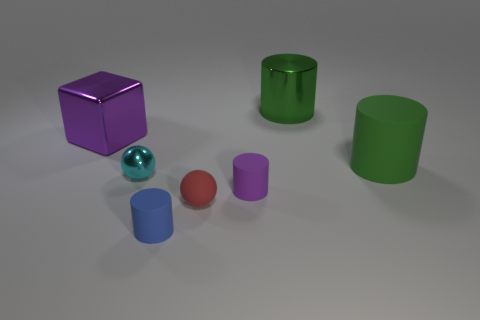Add 2 big purple metallic things. How many objects exist? 9 Subtract all cylinders. How many objects are left? 3 Add 3 metal cubes. How many metal cubes exist? 4 Subtract 0 brown cylinders. How many objects are left? 7 Subtract all big shiny cubes. Subtract all big purple blocks. How many objects are left? 5 Add 4 matte objects. How many matte objects are left? 8 